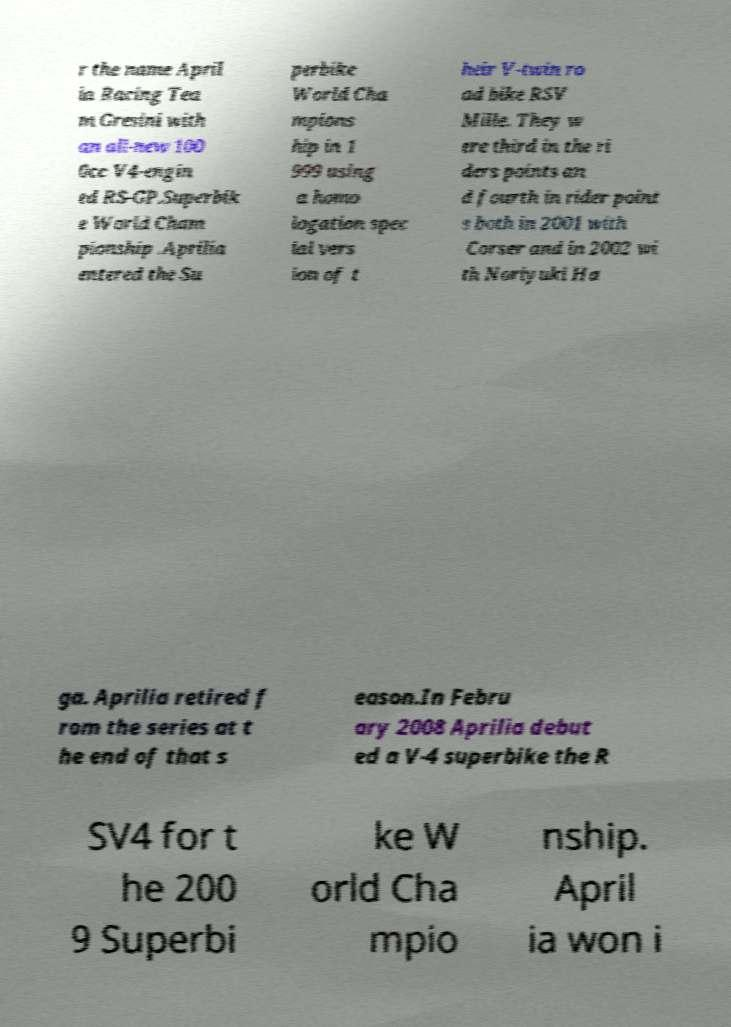Please read and relay the text visible in this image. What does it say? r the name April ia Racing Tea m Gresini with an all-new 100 0cc V4-engin ed RS-GP.Superbik e World Cham pionship .Aprilia entered the Su perbike World Cha mpions hip in 1 999 using a homo logation spec ial vers ion of t heir V-twin ro ad bike RSV Mille. They w ere third in the ri ders points an d fourth in rider point s both in 2001 with Corser and in 2002 wi th Noriyuki Ha ga. Aprilia retired f rom the series at t he end of that s eason.In Febru ary 2008 Aprilia debut ed a V-4 superbike the R SV4 for t he 200 9 Superbi ke W orld Cha mpio nship. April ia won i 